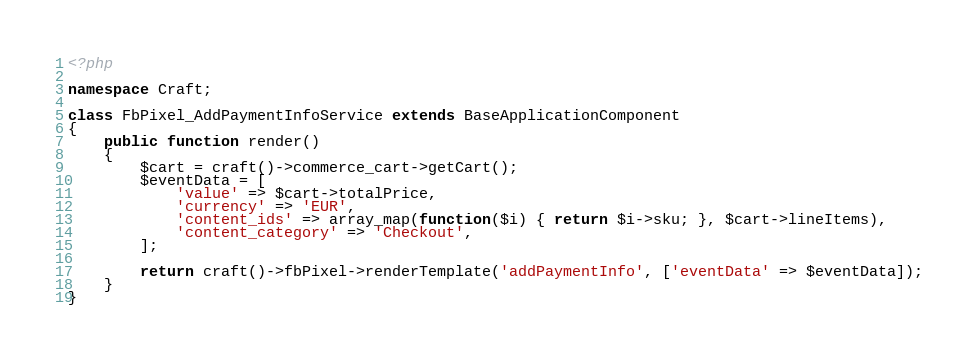<code> <loc_0><loc_0><loc_500><loc_500><_PHP_><?php

namespace Craft;

class FbPixel_AddPaymentInfoService extends BaseApplicationComponent
{
    public function render()
    {
        $cart = craft()->commerce_cart->getCart();
        $eventData = [
            'value' => $cart->totalPrice,
            'currency' => 'EUR',
            'content_ids' => array_map(function($i) { return $i->sku; }, $cart->lineItems),
            'content_category' => 'Checkout',
        ];

        return craft()->fbPixel->renderTemplate('addPaymentInfo', ['eventData' => $eventData]);
    }
}
</code> 